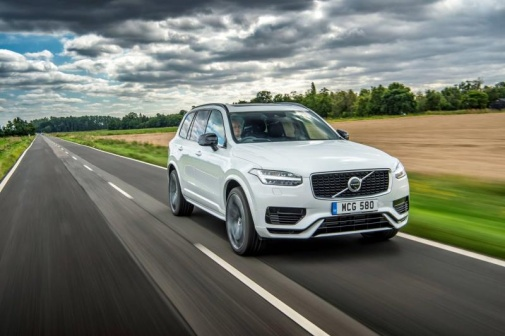Describe the weather in this image. The weather in the image appears to be cool and pleasant, with a sky filled with thick, fluffy clouds that suggest it may be partially sunny with occasional overcasts. The wet condition of the road indicates that it has recently rained, leaving the environment looking fresh and green, which adds to the overall serene and calming atmosphere. 